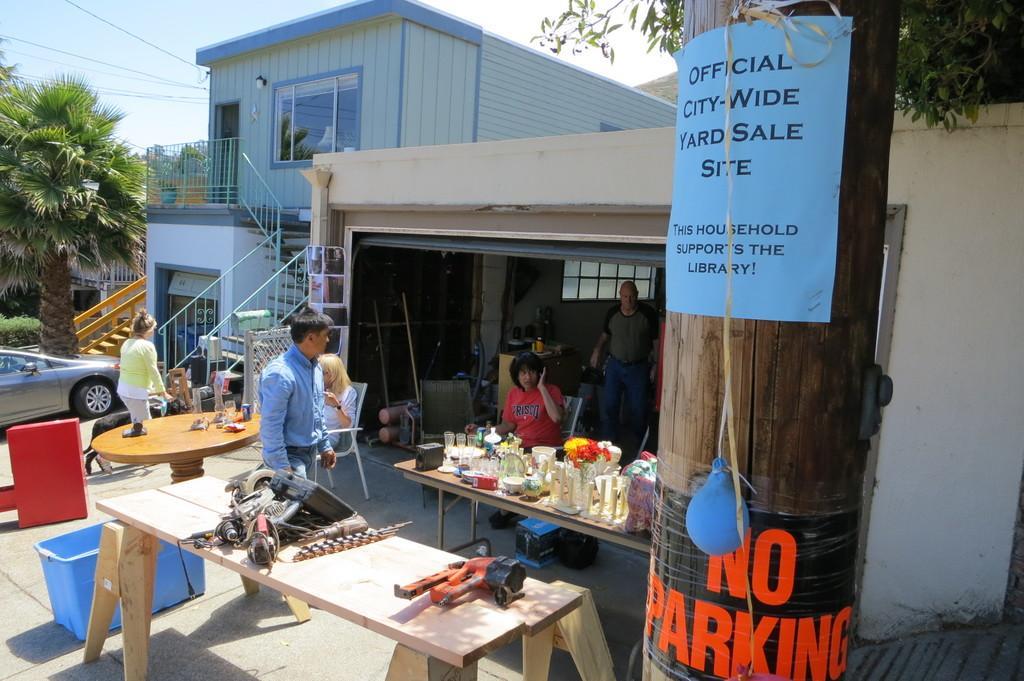How would you summarize this image in a sentence or two? In this image i can see a man standing at right two man, one man is sitting and the other man is standing, there are few bottles, a flower pot on a table, at the back ground i can see, a building, a tree, a car, stairs and a banner. 